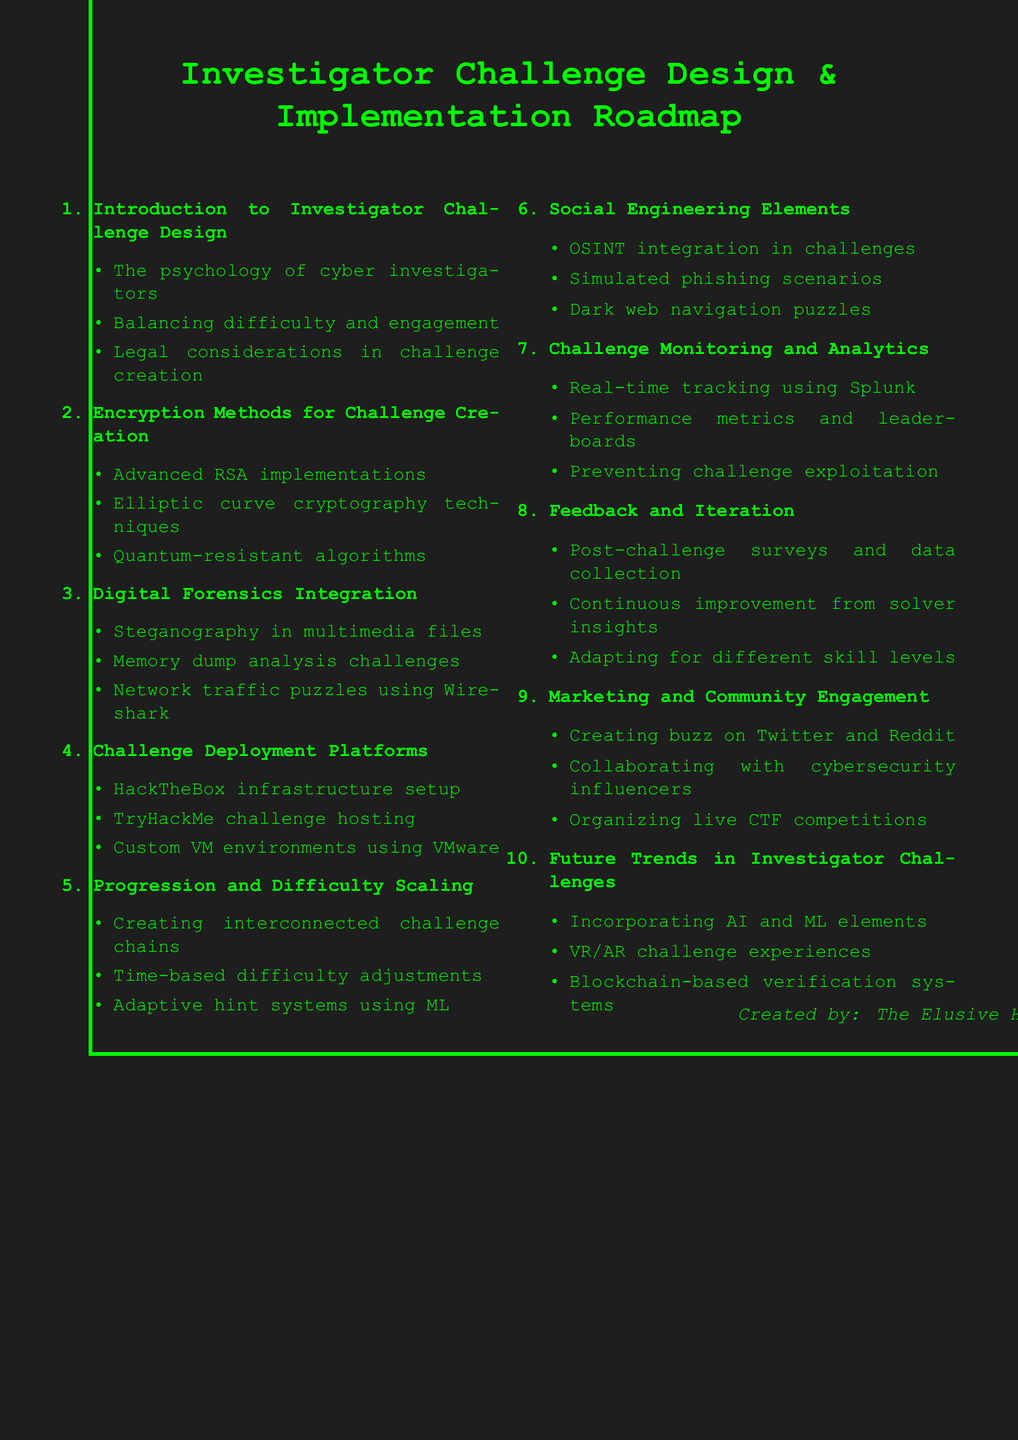What is the first section of the agenda? The first section introduces the topic of investigator challenge design, outlining its foundational elements.
Answer: Introduction to Investigator Challenge Design How many subsections are in the "Encryption Methods for Challenge Creation"? There are three subsections detailing various encryption methods used in challenges.
Answer: 3 What platform is mentioned for challenge deployment? The agenda lists multiple platforms that can be used to host challenges, emphasizing different infrastructure options.
Answer: HackTheBox What is one element included in social engineering challenges? The document discusses integrating various social engineering tactics into investigator challenges, providing realistic scenarios.
Answer: Simulated phishing scenarios Which analytics tool is highlighted for challenge monitoring? The document notes a specific tool used for real-time tracking of participants involved in challenges.
Answer: Splunk What type of feedback is emphasized in the iteration process? The emphasis is on gathering feedback from participants after challenges to inform future improvements.
Answer: Post-challenge surveys and data collection What future trend involves immersive technology? Incorporating new technologies into challenges is a key trend discussed for enhancing user experience.
Answer: VR/AR challenge experiences 